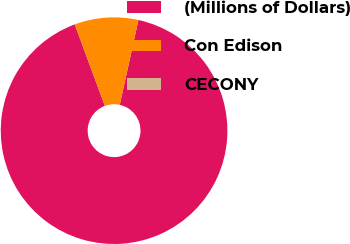Convert chart. <chart><loc_0><loc_0><loc_500><loc_500><pie_chart><fcel>(Millions of Dollars)<fcel>Con Edison<fcel>CECONY<nl><fcel>90.91%<fcel>9.09%<fcel>0.0%<nl></chart> 